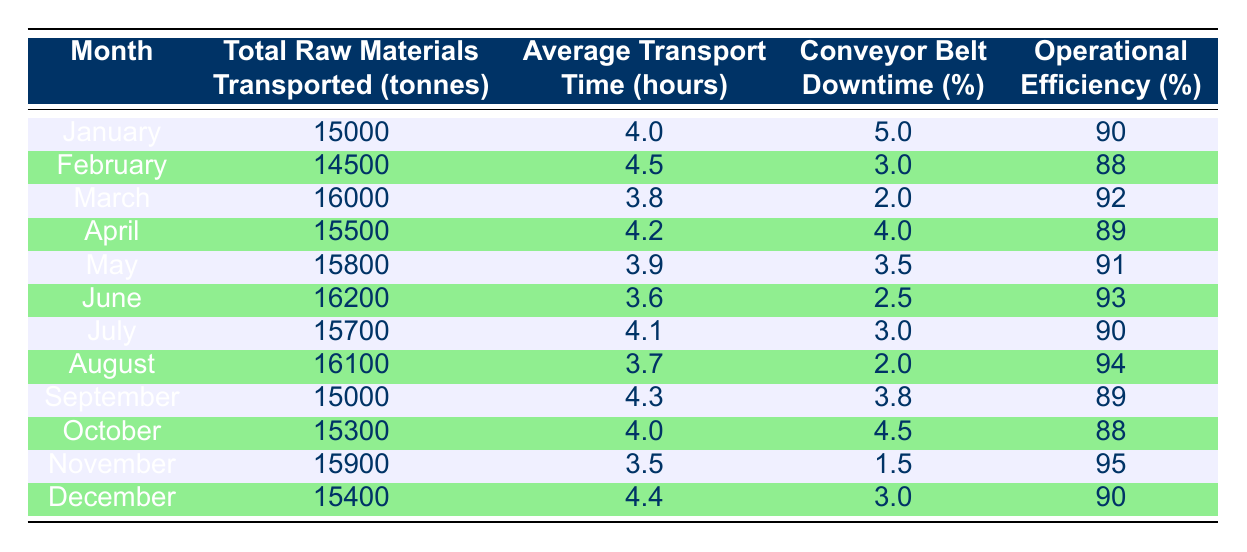What is the total amount of raw materials transported in March? The table states that in March, the "Total Raw Materials Transported" is listed as 16000 tonnes.
Answer: 16000 tonnes What was the average transport time in hours for the month of June? According to the table, the "Average Transport Time" for June is recorded as 3.6 hours.
Answer: 3.6 hours Which month had the highest operational efficiency, and what was the value? By inspecting the "Operational Efficiency" column, November has the highest value at 95%.
Answer: November, 95% What is the average conveyor belt downtime percentage for the year? To find the average conveyor belt downtime, sum all the monthly downtimes (5+3+2+4+3.5+2.5+3+2+3.8+4.5+1.5+3 = 36) and then divide by 12, resulting in an average of 3%.
Answer: 3% Was the total raw material transported in August greater than that in January? In August, the total was 16100 tonnes, while in January it was 15000 tonnes. Since 16100 is greater than 15000, the answer is yes.
Answer: Yes Which month had the lowest average transport time and what was that time? By reviewing the average transport times, June has the lowest average at 3.6 hours.
Answer: June, 3.6 hours In which month was the conveyor belt downtime the highest, and what percentage was it? Upon examining the "Conveyor Belt Downtime (%)" column, the highest downtime was 5%, recorded in January.
Answer: January, 5% How much more raw material was transported in November compared to February? Calculate the difference between the total raw materials for November (15900 tonnes) and February (14500 tonnes): 15900 - 14500 = 1400 tonnes.
Answer: 1400 tonnes What was the operational efficiency in April and how does it compare to the efficiency in June? The operational efficiency in April was 89%, while in June it was 93%. June's efficiency (93%) is higher compared to April's (89%).
Answer: April: 89%, June: 93% (June is higher) 